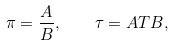<formula> <loc_0><loc_0><loc_500><loc_500>\pi = \frac { A } { B } , \quad \tau = A T B ,</formula> 